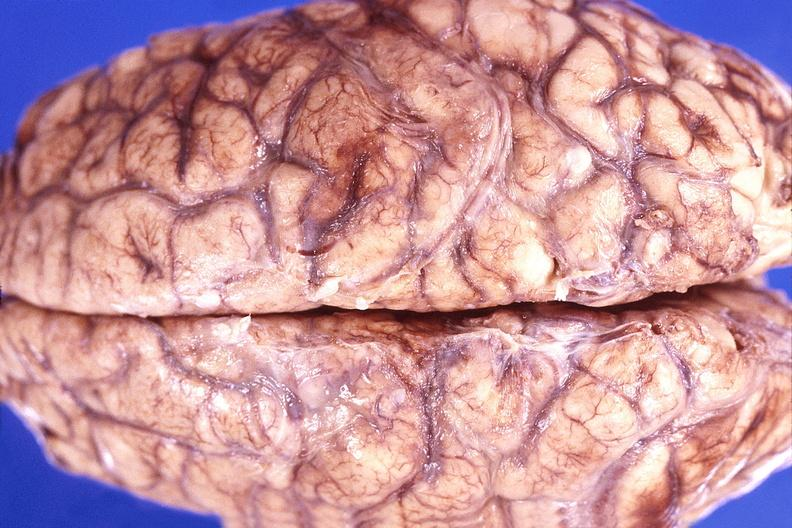s stillborn macerated present?
Answer the question using a single word or phrase. No 